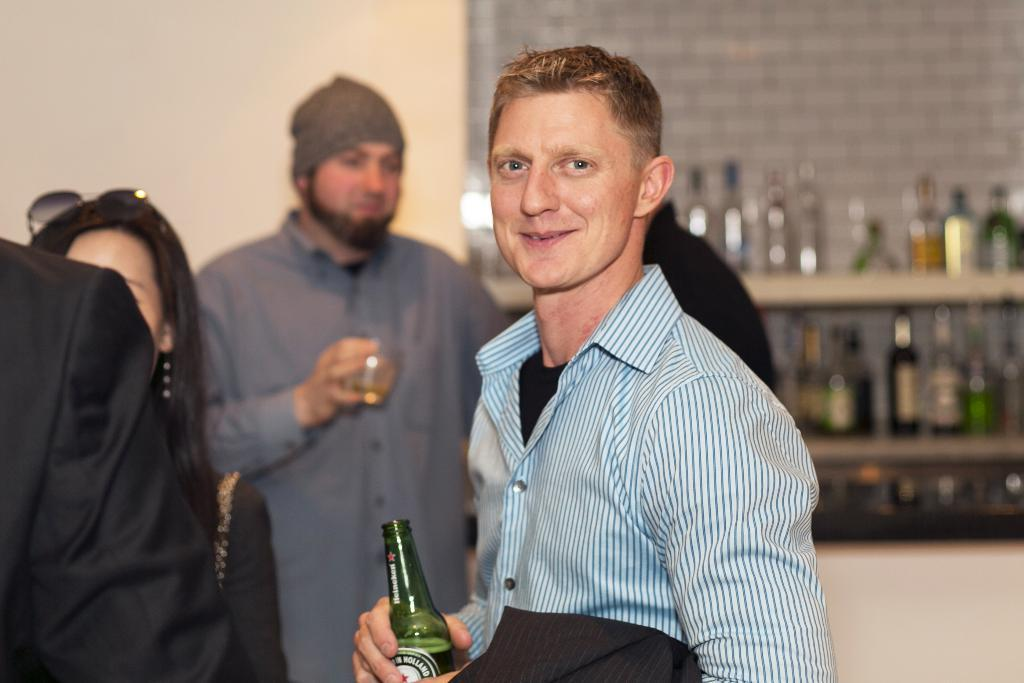What are the people in the image doing near the wall? The people in the image are standing near a wall. What can be seen inside the self in the image? There are bottles in a self in the image. Can you describe what the people holding objects are doing? Some people in the image are holding objects, but their actions are not specified. What type of cloud is visible in the image? There is no cloud visible in the image; it features people standing near a wall and bottles in a self. How many rings are being worn by the people in the image? There is no mention of rings in the image; it only mentions people standing near a wall and bottles in a self. 